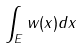<formula> <loc_0><loc_0><loc_500><loc_500>\int _ { E } w ( x ) d x</formula> 